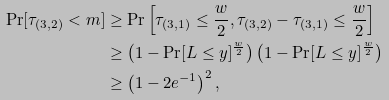Convert formula to latex. <formula><loc_0><loc_0><loc_500><loc_500>\Pr [ \tau _ { ( 3 , 2 ) } < m ] & \geq \Pr \left [ \tau _ { ( 3 , 1 ) } \leq \frac { w } { 2 } , \tau _ { ( 3 , 2 ) } - \tau _ { ( 3 , 1 ) } \leq \frac { w } { 2 } \right ] \\ & \geq \left ( 1 - \Pr [ L \leq y ] ^ { \frac { w } { 2 } } \right ) \left ( 1 - \Pr [ L \leq y ] ^ { \frac { w } { 2 } } \right ) \\ & \geq \left ( 1 - 2 e ^ { - 1 } \right ) ^ { 2 } ,</formula> 